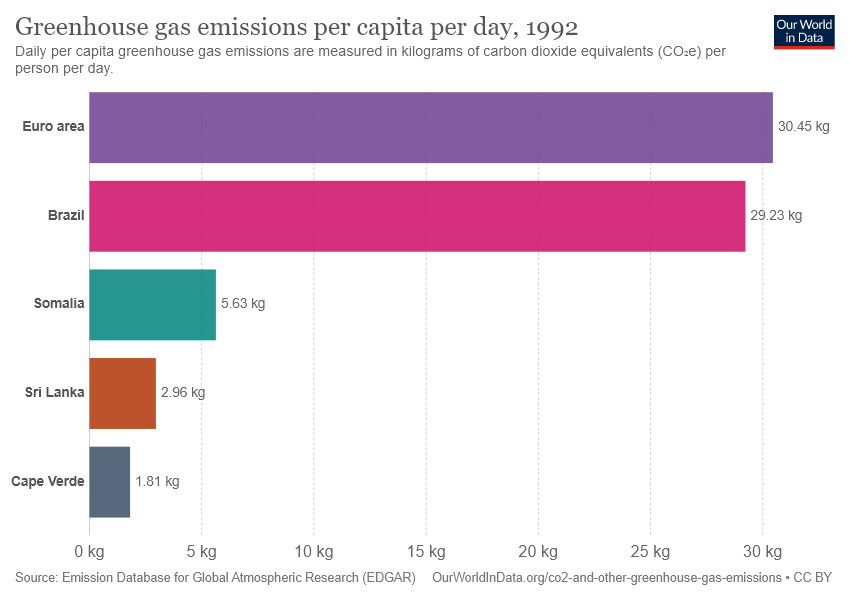Point out several critical features in this image. Please add the orange and green bars, with the total being 8.59. The Euro area has the lowest level of greenhouse gas emissions, while Somalia has the highest level of emissions. 